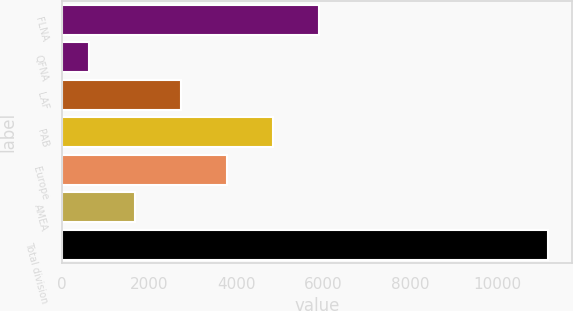<chart> <loc_0><loc_0><loc_500><loc_500><bar_chart><fcel>FLNA<fcel>QFNA<fcel>LAF<fcel>PAB<fcel>Europe<fcel>AMEA<fcel>Total division<nl><fcel>5887.5<fcel>617<fcel>2725.2<fcel>4833.4<fcel>3779.3<fcel>1671.1<fcel>11158<nl></chart> 